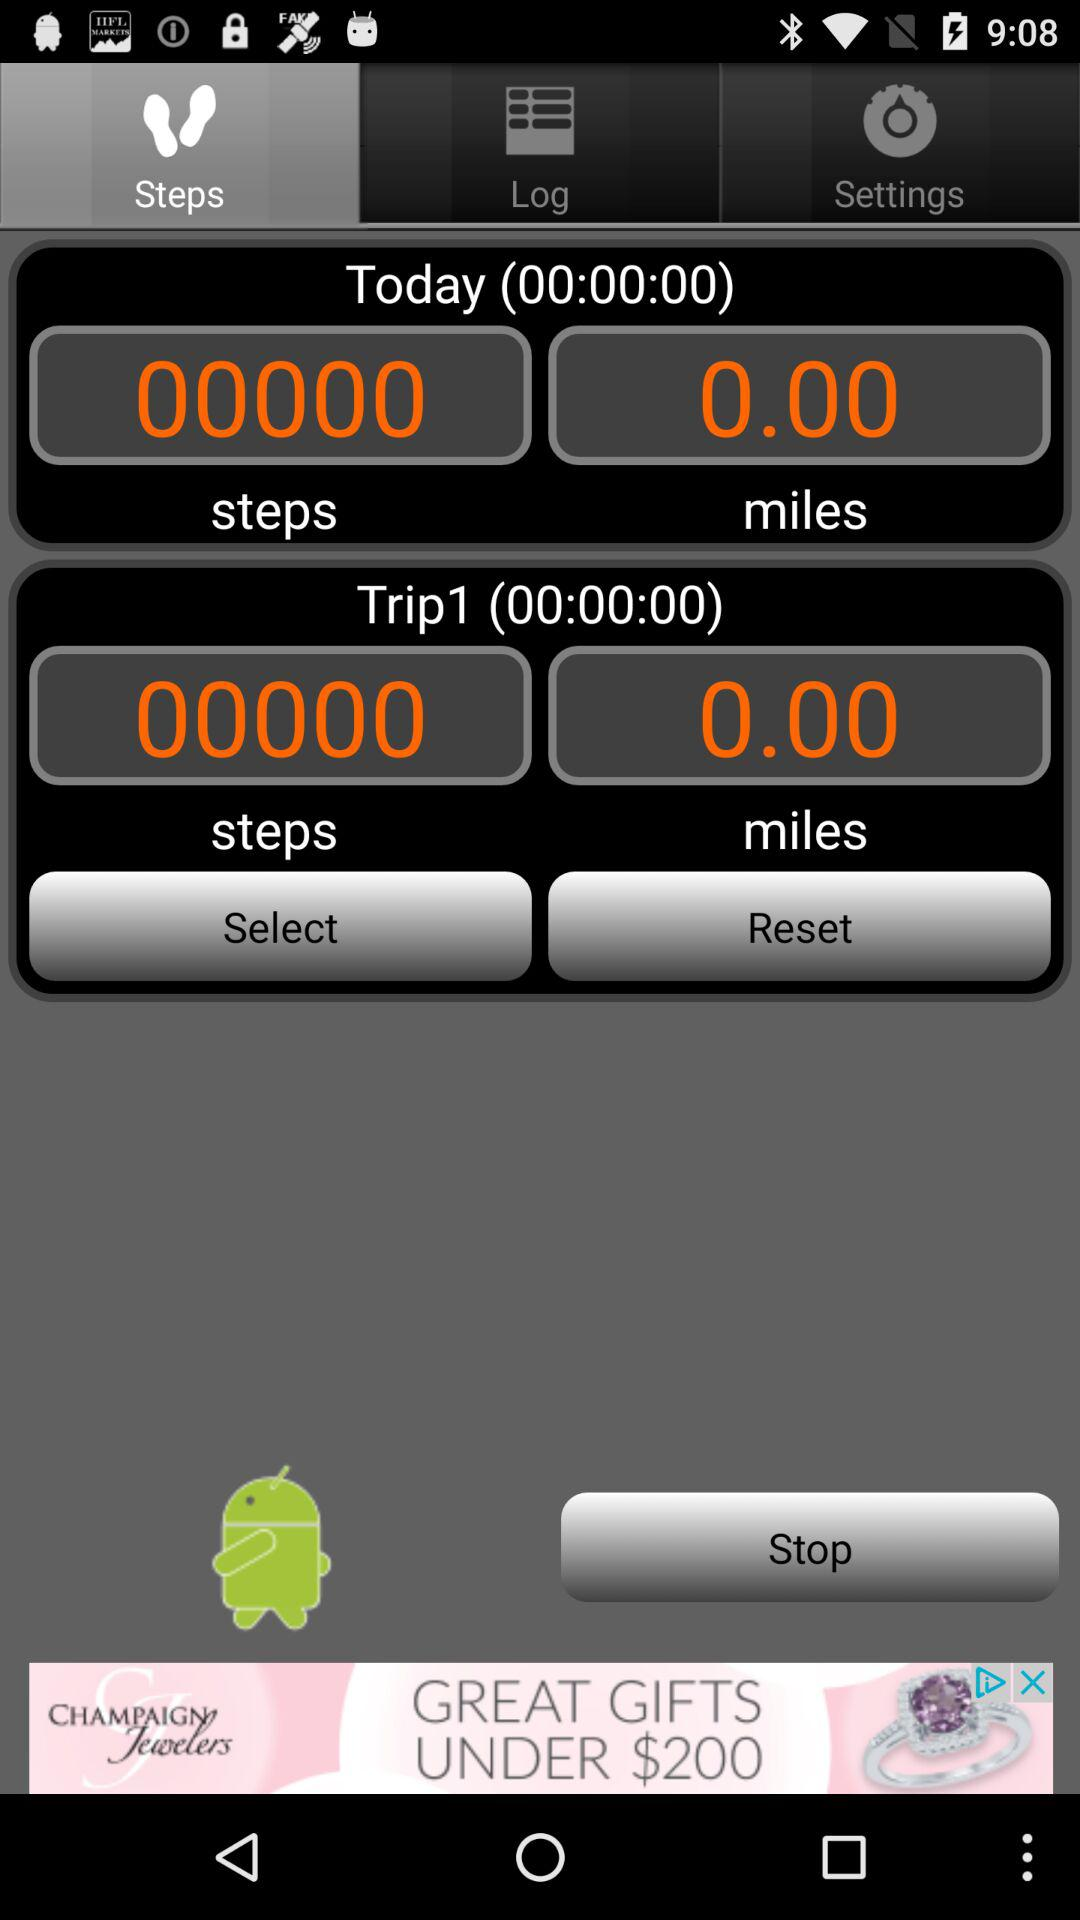How many steps are there in Trip1? There are 0 steps. 